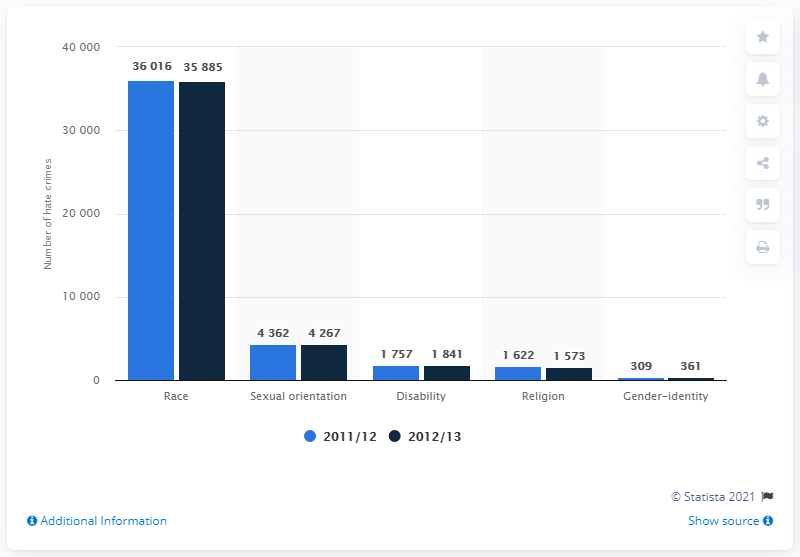Indicate a few pertinent items in this graphic. In 2012/13, race was the most common motivation for hate crimes in England and Wales. 